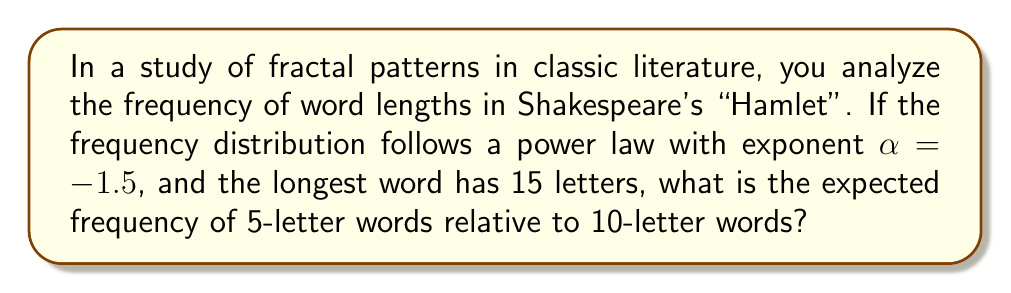Can you solve this math problem? To solve this problem, we'll use the power law distribution and the given information. Let's approach this step-by-step:

1) The power law distribution is given by:

   $$f(x) = Cx^{\alpha}$$

   where $C$ is a constant, $x$ is the word length, and $\alpha$ is the exponent.

2) We're interested in the ratio of frequencies for 5-letter words to 10-letter words. Let's call this ratio $R$:

   $$R = \frac{f(5)}{f(10)}$$

3) Substituting the power law formula:

   $$R = \frac{C5^{\alpha}}{C10^{\alpha}}$$

4) The constant $C$ cancels out:

   $$R = \frac{5^{\alpha}}{10^{\alpha}}$$

5) Now, we can substitute the given $\alpha = -1.5$:

   $$R = \frac{5^{-1.5}}{10^{-1.5}}$$

6) This can be rewritten as:

   $$R = \left(\frac{10}{5}\right)^{1.5} = 2^{1.5}$$

7) Calculate the result:

   $$R = 2^{1.5} \approx 2.8284$$

Therefore, 5-letter words are expected to be about 2.8284 times more frequent than 10-letter words in this analysis of "Hamlet".
Answer: $2^{1.5} \approx 2.8284$ 